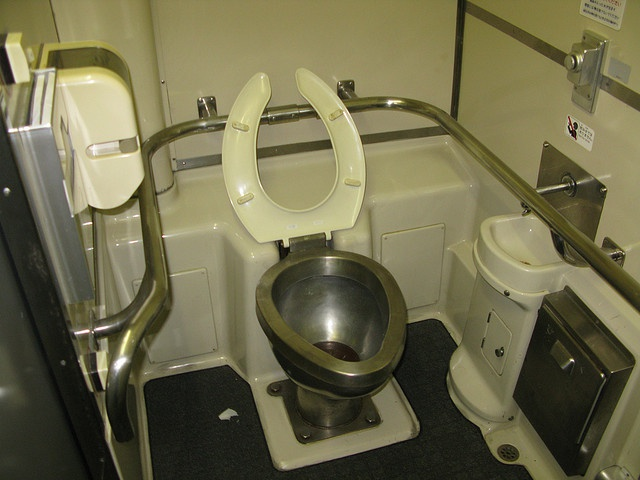Describe the objects in this image and their specific colors. I can see toilet in darkgreen, black, khaki, and tan tones and sink in darkgreen, tan, and olive tones in this image. 